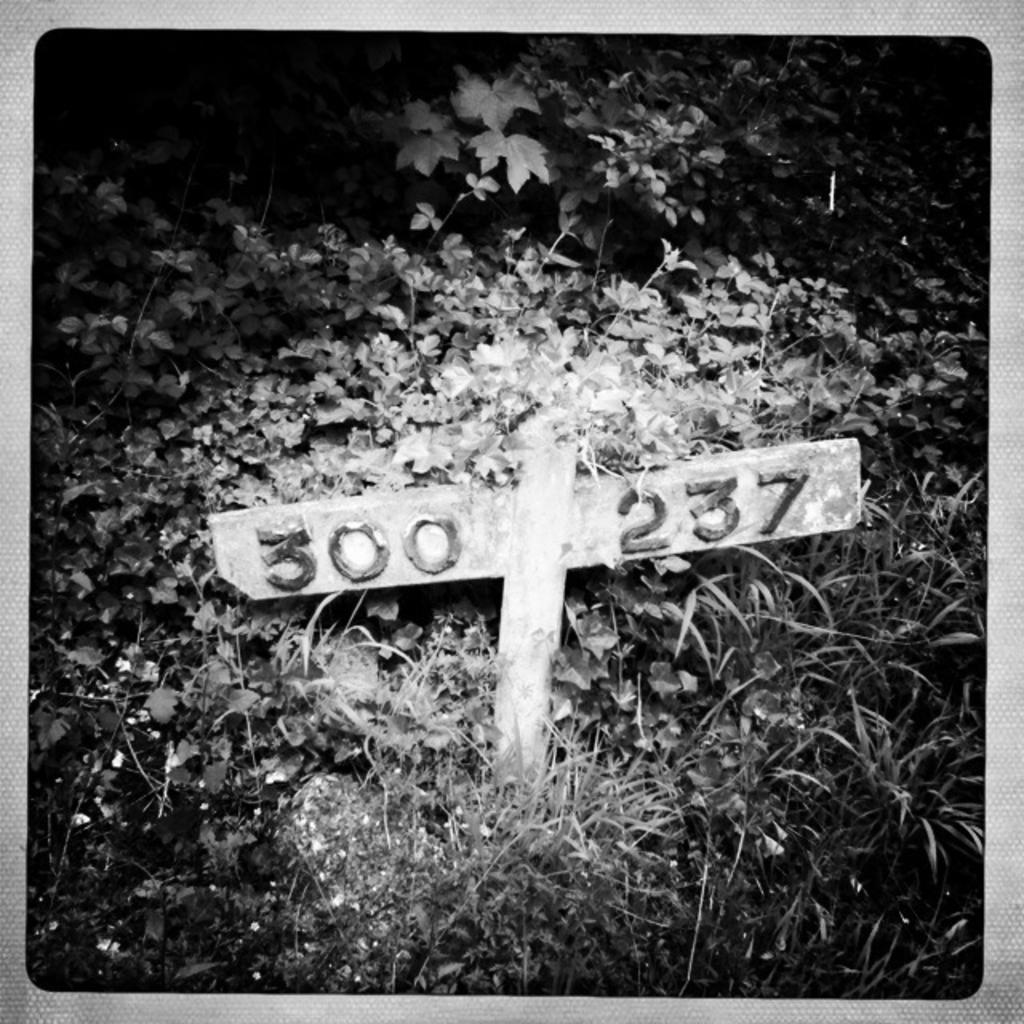<image>
Present a compact description of the photo's key features. A small posts indicates where 300 and 237 are located. 